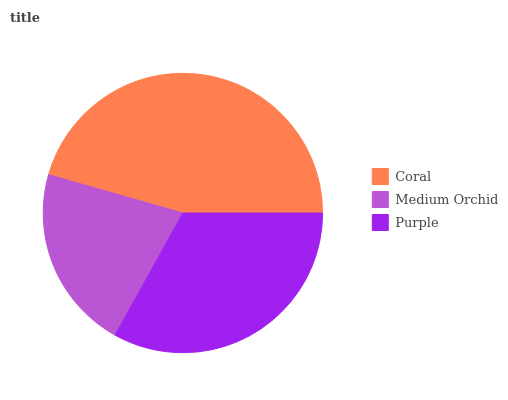Is Medium Orchid the minimum?
Answer yes or no. Yes. Is Coral the maximum?
Answer yes or no. Yes. Is Purple the minimum?
Answer yes or no. No. Is Purple the maximum?
Answer yes or no. No. Is Purple greater than Medium Orchid?
Answer yes or no. Yes. Is Medium Orchid less than Purple?
Answer yes or no. Yes. Is Medium Orchid greater than Purple?
Answer yes or no. No. Is Purple less than Medium Orchid?
Answer yes or no. No. Is Purple the high median?
Answer yes or no. Yes. Is Purple the low median?
Answer yes or no. Yes. Is Medium Orchid the high median?
Answer yes or no. No. Is Medium Orchid the low median?
Answer yes or no. No. 